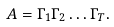<formula> <loc_0><loc_0><loc_500><loc_500>A = \Gamma _ { 1 } \Gamma _ { 2 } \dots \Gamma _ { T } .</formula> 